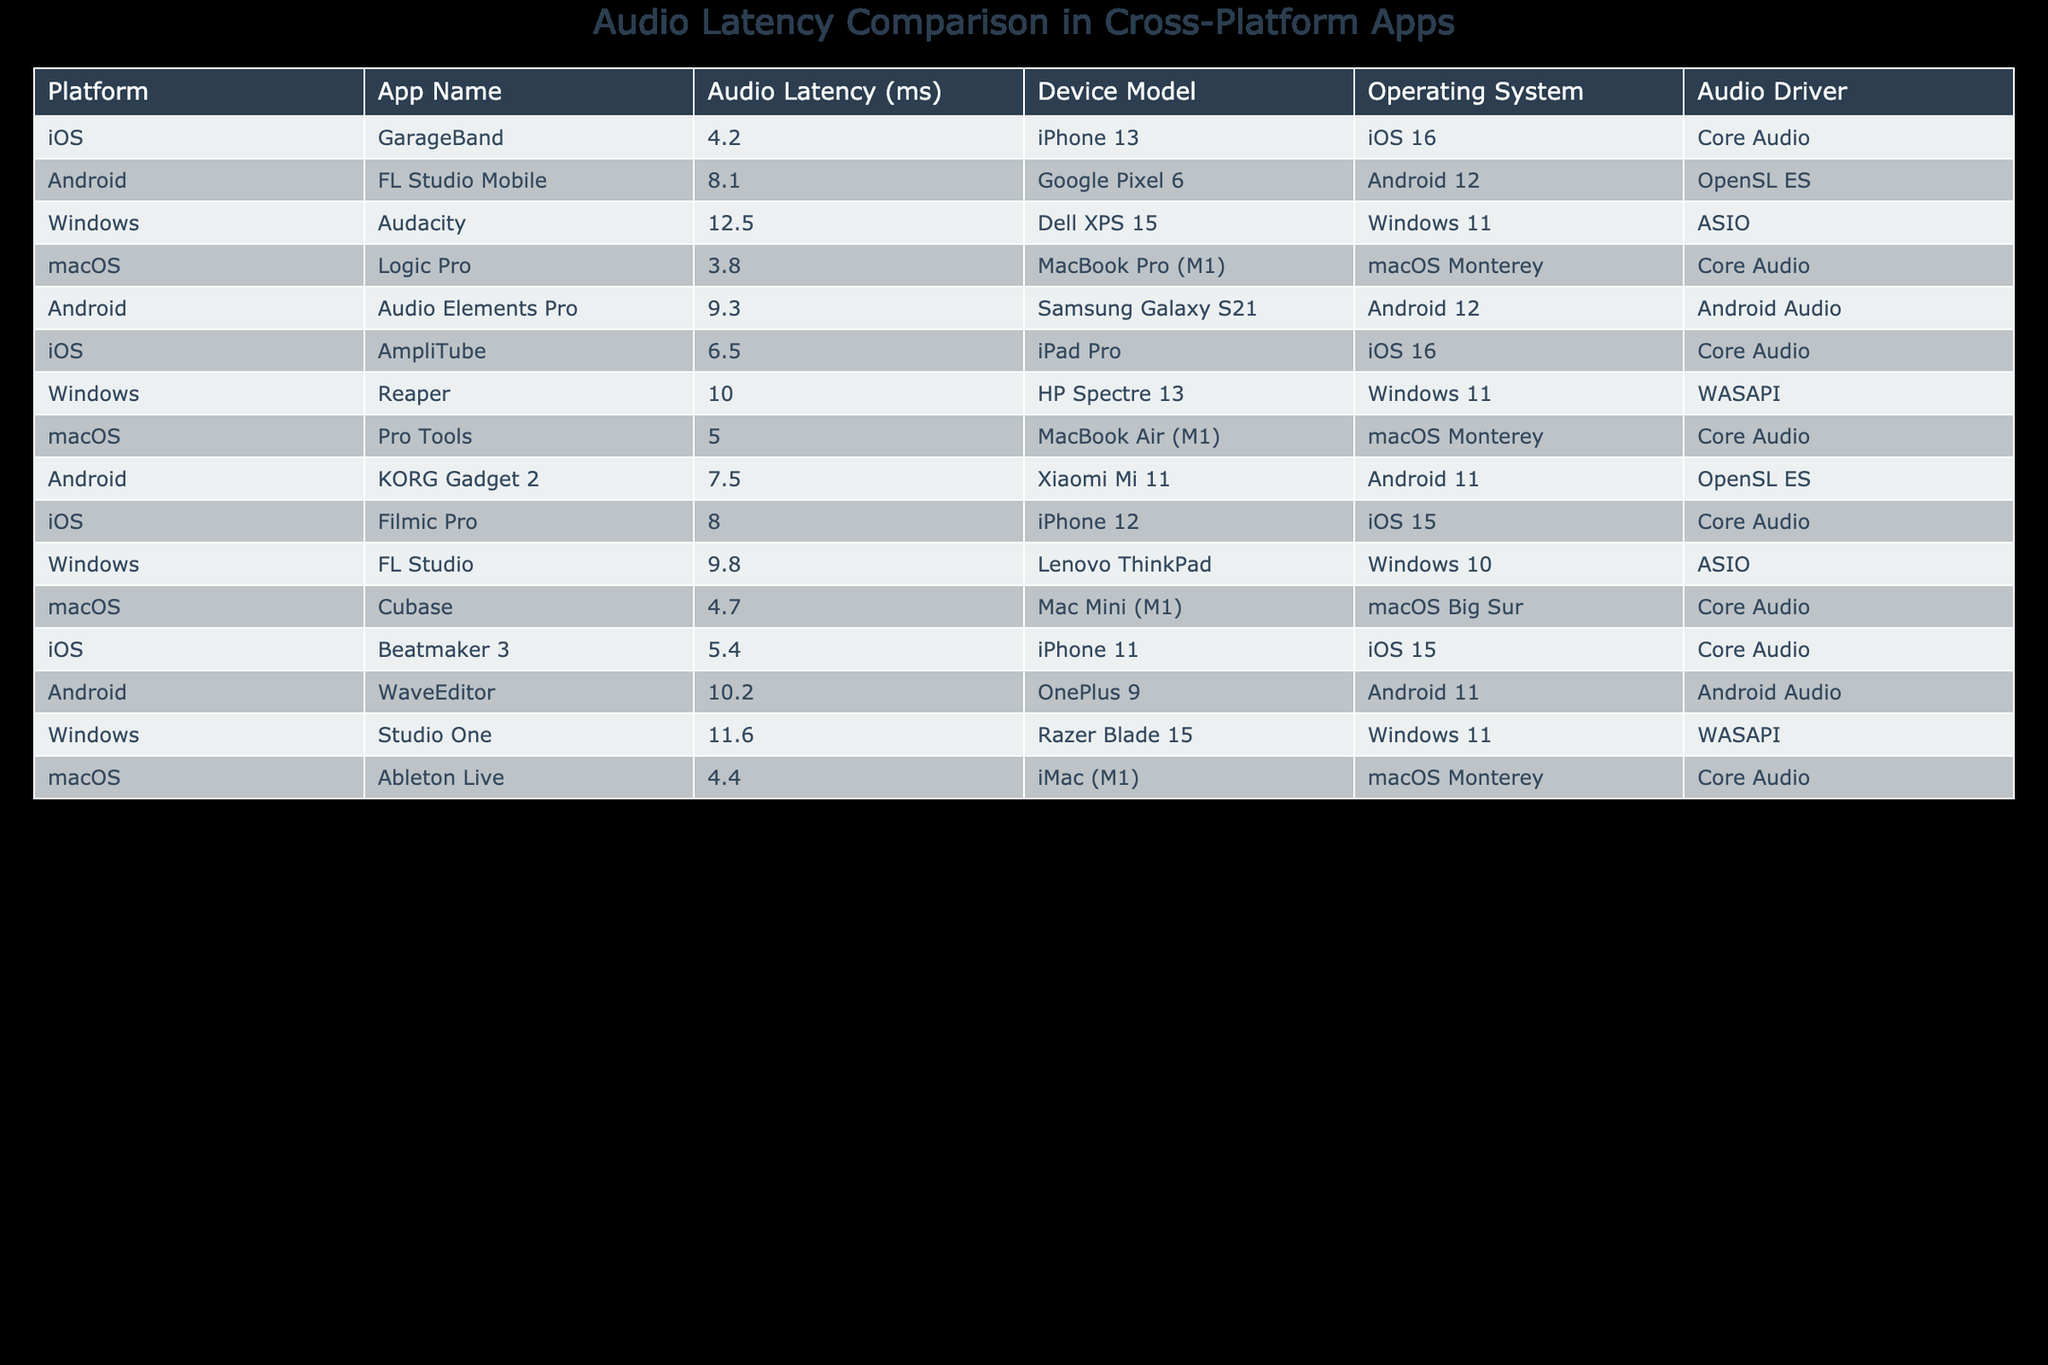What is the audio latency of GarageBand? The table shows the entry for GarageBand under the iOS platform with an audio latency measurement of 4.2 ms.
Answer: 4.2 ms Which app has the highest audio latency? By comparing all the audio latency values in the table, Studio One has the highest value at 11.6 ms.
Answer: 11.6 ms What is the difference in audio latency between iOS and Android apps? The lowest audio latency among iOS apps is 4.2 ms (GarageBand) and the highest among Android apps is 10.2 ms (WaveEditor). The difference between these two values is 10.2 - 4.2 = 6.0 ms.
Answer: 6.0 ms Is the audio latency of Logic Pro lower than that of Reaper? The table lists Logic Pro's audio latency as 3.8 ms and Reaper's as 10.0 ms. Since 3.8 ms is less than 10.0 ms, the answer is yes.
Answer: Yes What is the average audio latency of macOS apps? The audio latencies for macOS apps are: Logic Pro (3.8 ms), Pro Tools (5.0 ms), Cubase (4.7 ms), and Ableton Live (4.4 ms). The total is 3.8 + 5.0 + 4.7 + 4.4 = 18.9 ms, and there are 4 apps, so the average is 18.9 / 4 = 4.725 ms.
Answer: 4.725 ms Are there more Android apps with latency greater than 10 ms than iOS apps? The table shows that two Android apps (WaveEditor and FL Studio Mobile) have latency greater than 10 ms, while iOS apps do not exceed 8.0 ms. Thus, there are more Android apps with latency greater than 10 ms.
Answer: Yes What is the audio latency of AmpliTube compared to Beatmaker 3? The audio latency of AmpliTube is 6.5 ms while Beatmaker 3 is 5.4 ms. Thus, AmpliTube has a higher latency than Beatmaker 3 by 6.5 - 5.4 = 1.1 ms.
Answer: 1.1 ms Which platform has the lowest audio latency overall? The minimum audio latency in the table is 3.8 ms from Logic Pro on the macOS platform, making it the lowest overall.
Answer: macOS What percentage of the listed Windows apps have audio latency greater than 10 ms? The Windows apps listed are Audacity (12.5 ms), Reaper (10.0 ms), FL Studio (9.8 ms), and Studio One (11.6 ms). Out of these, Audacity and Studio One have latencies greater than 10 ms, which is 2 out of 4 apps. Thus, the percentage is (2/4) * 100 = 50%.
Answer: 50% 